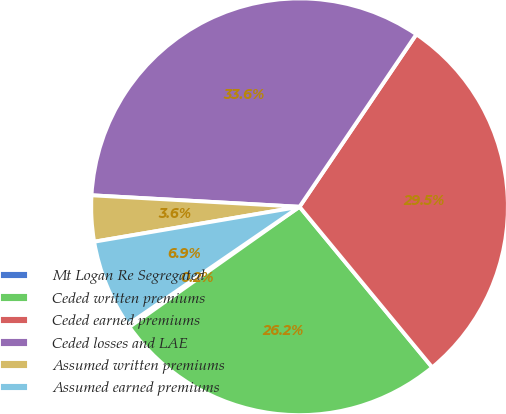Convert chart. <chart><loc_0><loc_0><loc_500><loc_500><pie_chart><fcel>Mt Logan Re Segregated<fcel>Ceded written premiums<fcel>Ceded earned premiums<fcel>Ceded losses and LAE<fcel>Assumed written premiums<fcel>Assumed earned premiums<nl><fcel>0.22%<fcel>26.2%<fcel>29.54%<fcel>33.6%<fcel>3.56%<fcel>6.89%<nl></chart> 